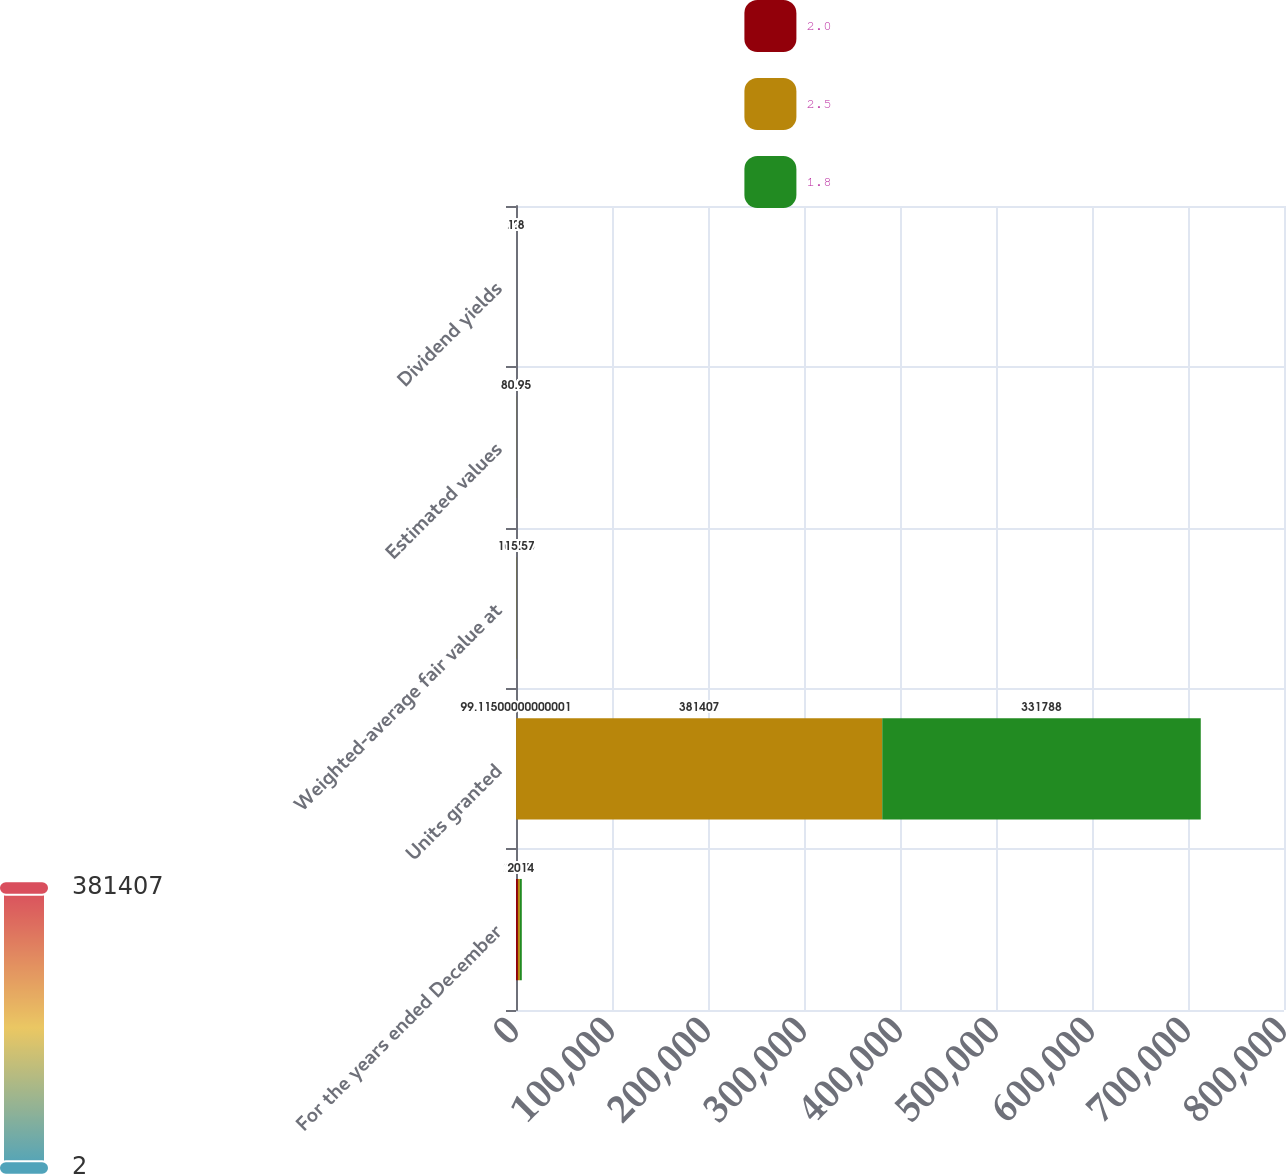<chart> <loc_0><loc_0><loc_500><loc_500><stacked_bar_chart><ecel><fcel>For the years ended December<fcel>Units granted<fcel>Weighted-average fair value at<fcel>Estimated values<fcel>Dividend yields<nl><fcel>2<fcel>2016<fcel>99.115<fcel>93.55<fcel>38.02<fcel>2.5<nl><fcel>2.5<fcel>2015<fcel>381407<fcel>104.68<fcel>61.22<fcel>2<nl><fcel>1.8<fcel>2014<fcel>331788<fcel>115.57<fcel>80.95<fcel>1.8<nl></chart> 